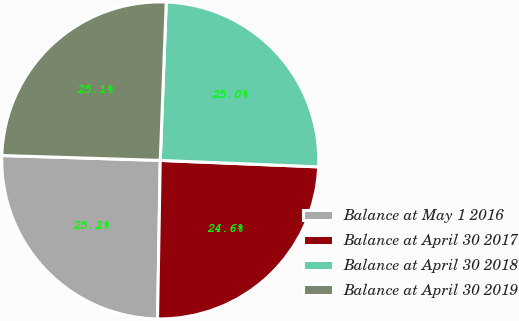<chart> <loc_0><loc_0><loc_500><loc_500><pie_chart><fcel>Balance at May 1 2016<fcel>Balance at April 30 2017<fcel>Balance at April 30 2018<fcel>Balance at April 30 2019<nl><fcel>25.22%<fcel>24.62%<fcel>25.05%<fcel>25.11%<nl></chart> 